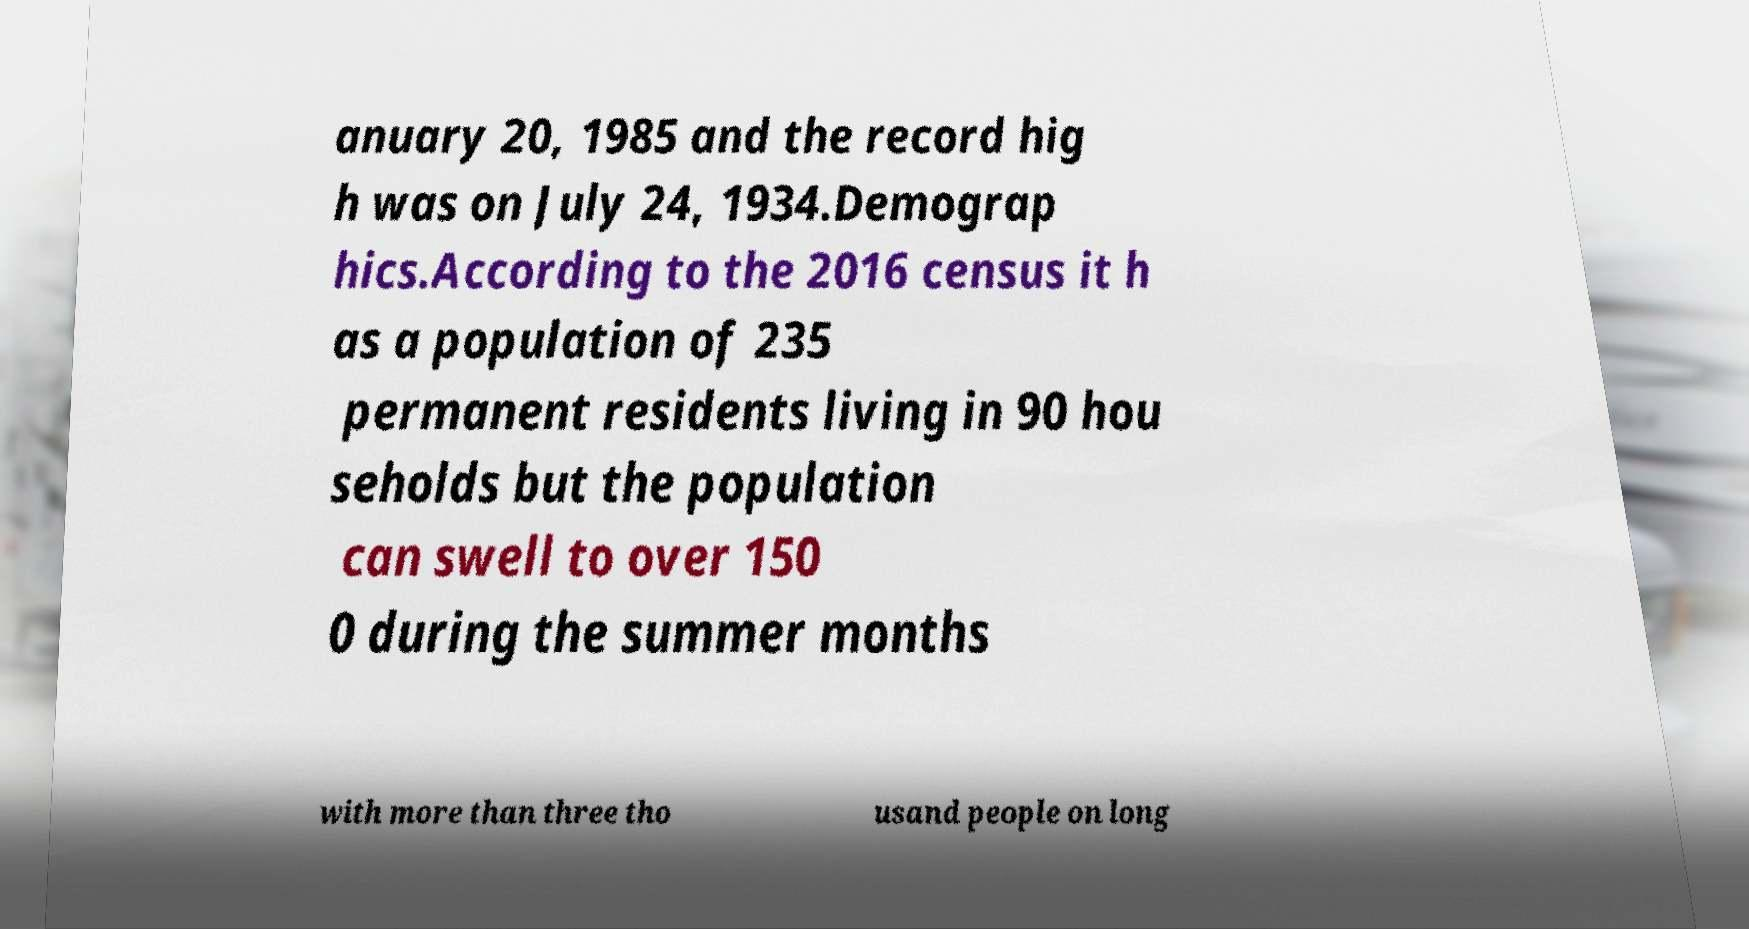For documentation purposes, I need the text within this image transcribed. Could you provide that? anuary 20, 1985 and the record hig h was on July 24, 1934.Demograp hics.According to the 2016 census it h as a population of 235 permanent residents living in 90 hou seholds but the population can swell to over 150 0 during the summer months with more than three tho usand people on long 